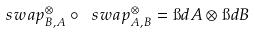Convert formula to latex. <formula><loc_0><loc_0><loc_500><loc_500>\ s w a p ^ { \otimes } _ { B , A } \circ \ s w a p ^ { \otimes } _ { A , B } = \i d { A } \otimes \i d { B }</formula> 